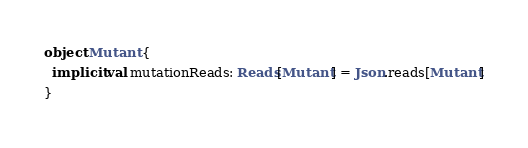<code> <loc_0><loc_0><loc_500><loc_500><_Scala_>
object Mutant {
  implicit val mutationReads: Reads[Mutant] = Json.reads[Mutant]
}
</code> 